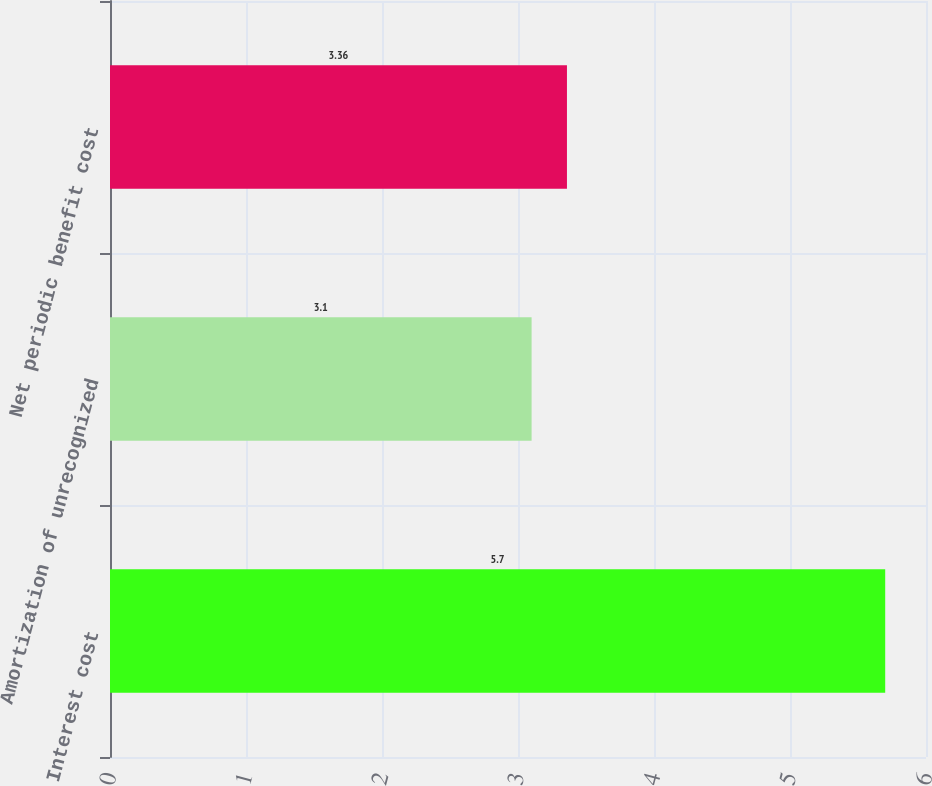Convert chart. <chart><loc_0><loc_0><loc_500><loc_500><bar_chart><fcel>Interest cost<fcel>Amortization of unrecognized<fcel>Net periodic benefit cost<nl><fcel>5.7<fcel>3.1<fcel>3.36<nl></chart> 